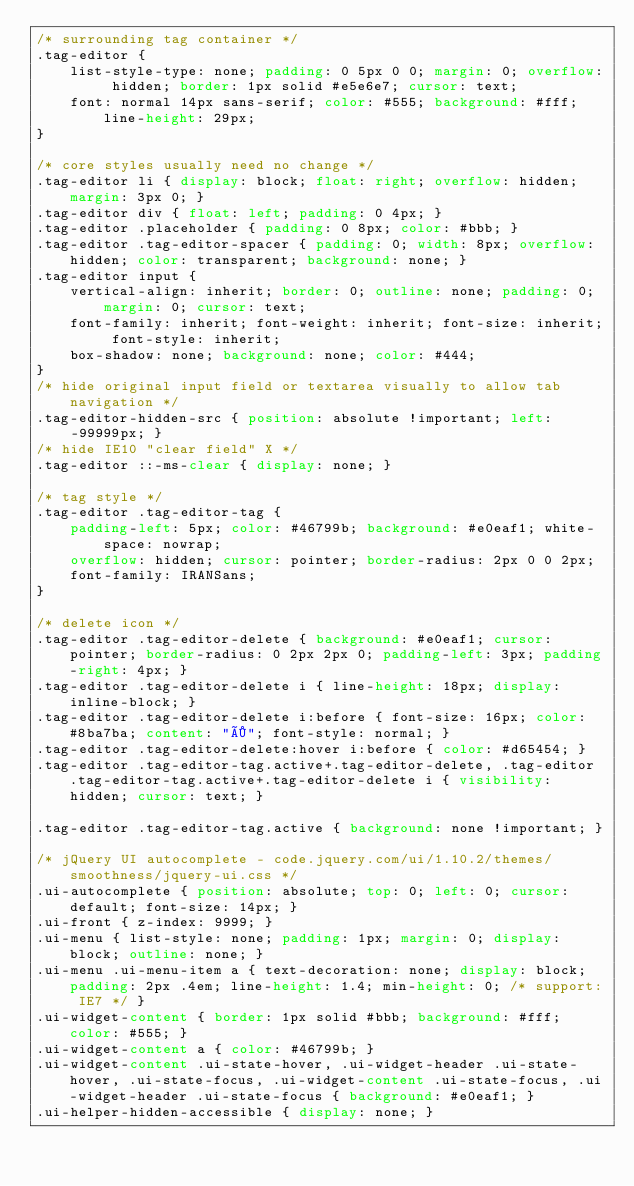<code> <loc_0><loc_0><loc_500><loc_500><_CSS_>/* surrounding tag container */
.tag-editor {
    list-style-type: none; padding: 0 5px 0 0; margin: 0; overflow: hidden; border: 1px solid #e5e6e7; cursor: text;
    font: normal 14px sans-serif; color: #555; background: #fff; line-height: 29px;
}

/* core styles usually need no change */
.tag-editor li { display: block; float: right; overflow: hidden; margin: 3px 0; }
.tag-editor div { float: left; padding: 0 4px; }
.tag-editor .placeholder { padding: 0 8px; color: #bbb; }
.tag-editor .tag-editor-spacer { padding: 0; width: 8px; overflow: hidden; color: transparent; background: none; }
.tag-editor input {
    vertical-align: inherit; border: 0; outline: none; padding: 0; margin: 0; cursor: text;
    font-family: inherit; font-weight: inherit; font-size: inherit; font-style: inherit;
    box-shadow: none; background: none; color: #444;
}
/* hide original input field or textarea visually to allow tab navigation */
.tag-editor-hidden-src { position: absolute !important; left: -99999px; }
/* hide IE10 "clear field" X */
.tag-editor ::-ms-clear { display: none; }

/* tag style */
.tag-editor .tag-editor-tag {
    padding-left: 5px; color: #46799b; background: #e0eaf1; white-space: nowrap;
    overflow: hidden; cursor: pointer; border-radius: 2px 0 0 2px;
    font-family: IRANSans;
}

/* delete icon */
.tag-editor .tag-editor-delete { background: #e0eaf1; cursor: pointer; border-radius: 0 2px 2px 0; padding-left: 3px; padding-right: 4px; }
.tag-editor .tag-editor-delete i { line-height: 18px; display: inline-block; }
.tag-editor .tag-editor-delete i:before { font-size: 16px; color: #8ba7ba; content: "×"; font-style: normal; }
.tag-editor .tag-editor-delete:hover i:before { color: #d65454; }
.tag-editor .tag-editor-tag.active+.tag-editor-delete, .tag-editor .tag-editor-tag.active+.tag-editor-delete i { visibility: hidden; cursor: text; }

.tag-editor .tag-editor-tag.active { background: none !important; }

/* jQuery UI autocomplete - code.jquery.com/ui/1.10.2/themes/smoothness/jquery-ui.css */
.ui-autocomplete { position: absolute; top: 0; left: 0; cursor: default; font-size: 14px; }
.ui-front { z-index: 9999; }
.ui-menu { list-style: none; padding: 1px; margin: 0; display: block; outline: none; }
.ui-menu .ui-menu-item a { text-decoration: none; display: block; padding: 2px .4em; line-height: 1.4; min-height: 0; /* support: IE7 */ }
.ui-widget-content { border: 1px solid #bbb; background: #fff; color: #555; }
.ui-widget-content a { color: #46799b; }
.ui-widget-content .ui-state-hover, .ui-widget-header .ui-state-hover, .ui-state-focus, .ui-widget-content .ui-state-focus, .ui-widget-header .ui-state-focus { background: #e0eaf1; }
.ui-helper-hidden-accessible { display: none; }
</code> 